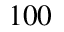Convert formula to latex. <formula><loc_0><loc_0><loc_500><loc_500>1 0 0</formula> 